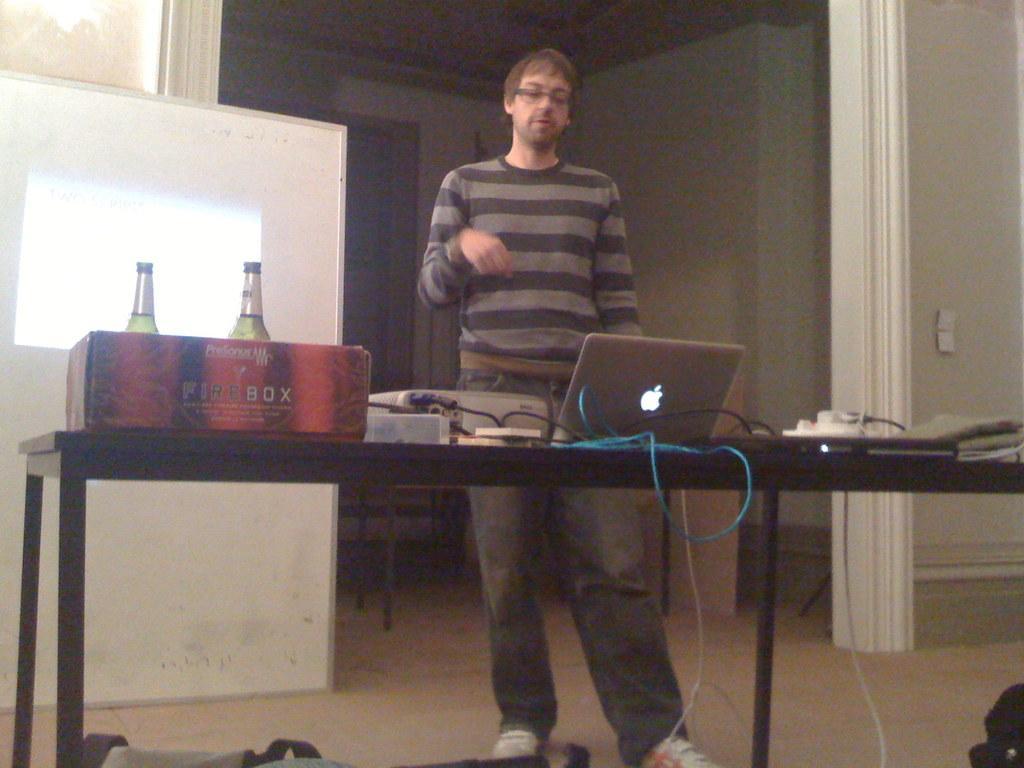In one or two sentences, can you explain what this image depicts? In this picture we can see a table, there is a laptop, a switch board, a projector, two bottles, a box present on the table, we can see a man standing in front of the table, on the left side there is a projector screen, in the background there is a wall. 